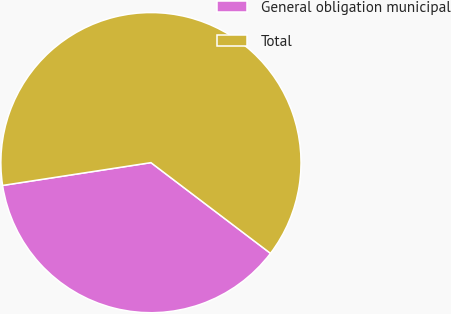<chart> <loc_0><loc_0><loc_500><loc_500><pie_chart><fcel>General obligation municipal<fcel>Total<nl><fcel>37.24%<fcel>62.76%<nl></chart> 